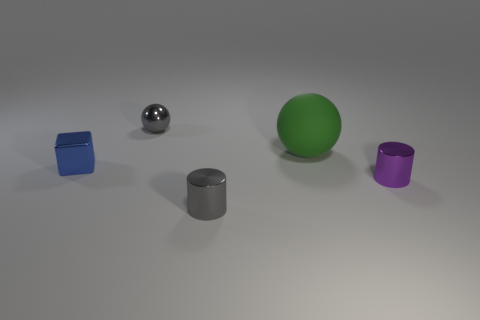What seems to be the setting for these objects? The objects appear to be placed on a flat, lightly textured surface that could resemble a simple tabletop or a studio environment. The uniform lighting and neutral backdrop suggest a controlled setting, possibly for a display or an experiment in object characteristics such as shape, texture, and color. 